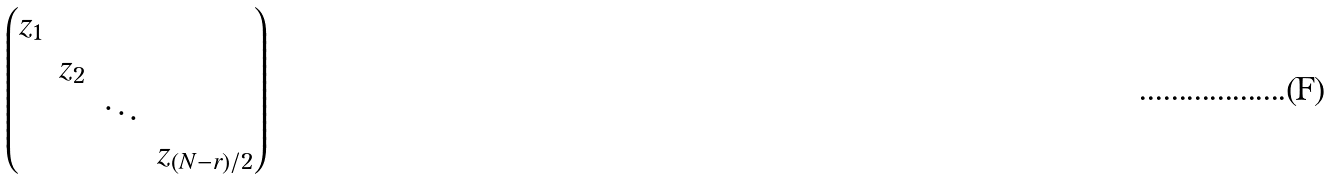<formula> <loc_0><loc_0><loc_500><loc_500>\begin{pmatrix} z _ { 1 } & & & \\ & z _ { 2 } & & \\ & & \ddots & \\ & & & z _ { ( N - r ) / 2 } \end{pmatrix}</formula> 